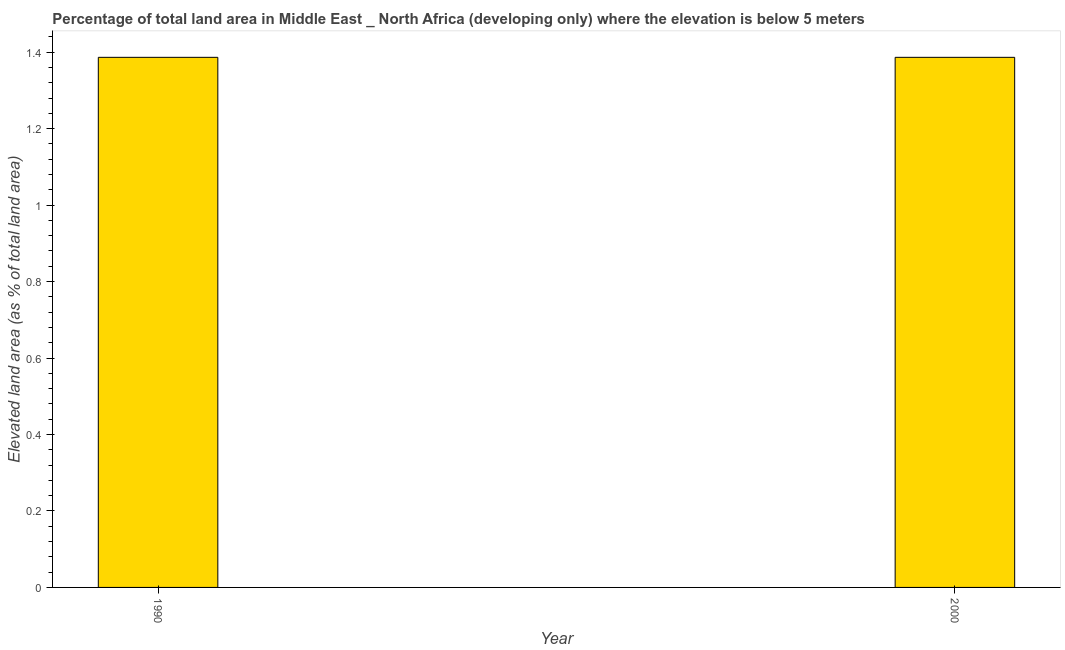Does the graph contain any zero values?
Offer a terse response. No. What is the title of the graph?
Ensure brevity in your answer.  Percentage of total land area in Middle East _ North Africa (developing only) where the elevation is below 5 meters. What is the label or title of the X-axis?
Your answer should be compact. Year. What is the label or title of the Y-axis?
Offer a very short reply. Elevated land area (as % of total land area). What is the total elevated land area in 1990?
Offer a very short reply. 1.39. Across all years, what is the maximum total elevated land area?
Provide a short and direct response. 1.39. Across all years, what is the minimum total elevated land area?
Make the answer very short. 1.39. In which year was the total elevated land area maximum?
Your response must be concise. 1990. What is the sum of the total elevated land area?
Make the answer very short. 2.77. What is the average total elevated land area per year?
Your response must be concise. 1.39. What is the median total elevated land area?
Keep it short and to the point. 1.39. Do a majority of the years between 1990 and 2000 (inclusive) have total elevated land area greater than 1.28 %?
Offer a very short reply. Yes. In how many years, is the total elevated land area greater than the average total elevated land area taken over all years?
Make the answer very short. 0. How many bars are there?
Provide a succinct answer. 2. What is the Elevated land area (as % of total land area) of 1990?
Offer a very short reply. 1.39. What is the Elevated land area (as % of total land area) of 2000?
Provide a succinct answer. 1.39. What is the ratio of the Elevated land area (as % of total land area) in 1990 to that in 2000?
Your answer should be very brief. 1. 